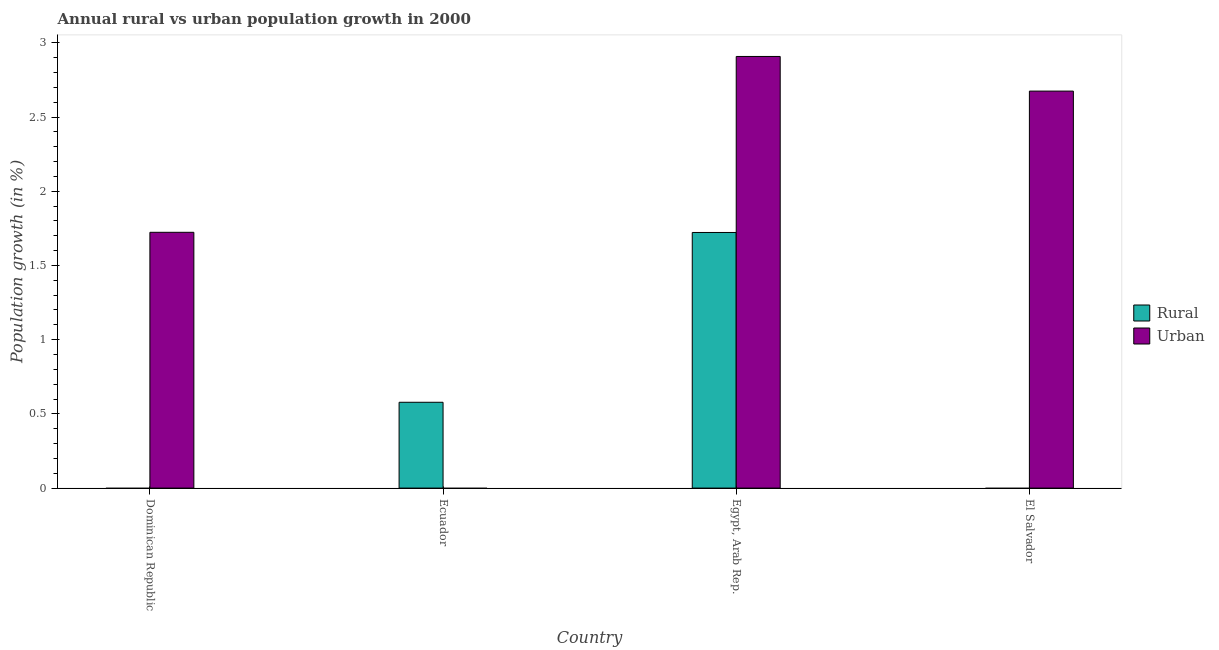How many different coloured bars are there?
Give a very brief answer. 2. Are the number of bars per tick equal to the number of legend labels?
Make the answer very short. No. How many bars are there on the 1st tick from the left?
Provide a short and direct response. 1. What is the label of the 4th group of bars from the left?
Your response must be concise. El Salvador. In how many cases, is the number of bars for a given country not equal to the number of legend labels?
Your answer should be very brief. 3. Across all countries, what is the maximum urban population growth?
Give a very brief answer. 2.91. In which country was the urban population growth maximum?
Offer a terse response. Egypt, Arab Rep. What is the total rural population growth in the graph?
Your answer should be compact. 2.3. What is the difference between the rural population growth in Ecuador and that in Egypt, Arab Rep.?
Provide a short and direct response. -1.14. What is the difference between the rural population growth in Ecuador and the urban population growth in Egypt, Arab Rep.?
Keep it short and to the point. -2.33. What is the average rural population growth per country?
Provide a short and direct response. 0.58. What is the difference between the rural population growth and urban population growth in Egypt, Arab Rep.?
Offer a terse response. -1.19. In how many countries, is the rural population growth greater than 0.8 %?
Offer a very short reply. 1. What is the ratio of the rural population growth in Ecuador to that in Egypt, Arab Rep.?
Ensure brevity in your answer.  0.34. Is the urban population growth in Dominican Republic less than that in El Salvador?
Provide a succinct answer. Yes. What is the difference between the highest and the second highest urban population growth?
Your response must be concise. 0.23. What is the difference between the highest and the lowest urban population growth?
Provide a short and direct response. 2.91. Is the sum of the urban population growth in Dominican Republic and El Salvador greater than the maximum rural population growth across all countries?
Make the answer very short. Yes. How many bars are there?
Provide a succinct answer. 5. Are all the bars in the graph horizontal?
Provide a succinct answer. No. How are the legend labels stacked?
Your answer should be compact. Vertical. What is the title of the graph?
Give a very brief answer. Annual rural vs urban population growth in 2000. What is the label or title of the X-axis?
Your answer should be very brief. Country. What is the label or title of the Y-axis?
Make the answer very short. Population growth (in %). What is the Population growth (in %) in Rural in Dominican Republic?
Offer a terse response. 0. What is the Population growth (in %) in Urban  in Dominican Republic?
Provide a succinct answer. 1.72. What is the Population growth (in %) of Rural in Ecuador?
Your answer should be compact. 0.58. What is the Population growth (in %) in Urban  in Ecuador?
Offer a very short reply. 0. What is the Population growth (in %) in Rural in Egypt, Arab Rep.?
Your answer should be very brief. 1.72. What is the Population growth (in %) in Urban  in Egypt, Arab Rep.?
Provide a short and direct response. 2.91. What is the Population growth (in %) in Rural in El Salvador?
Provide a short and direct response. 0. What is the Population growth (in %) of Urban  in El Salvador?
Keep it short and to the point. 2.67. Across all countries, what is the maximum Population growth (in %) in Rural?
Your answer should be very brief. 1.72. Across all countries, what is the maximum Population growth (in %) in Urban ?
Provide a succinct answer. 2.91. Across all countries, what is the minimum Population growth (in %) of Urban ?
Ensure brevity in your answer.  0. What is the total Population growth (in %) of Rural in the graph?
Give a very brief answer. 2.3. What is the total Population growth (in %) in Urban  in the graph?
Your response must be concise. 7.31. What is the difference between the Population growth (in %) in Urban  in Dominican Republic and that in Egypt, Arab Rep.?
Your answer should be very brief. -1.18. What is the difference between the Population growth (in %) in Urban  in Dominican Republic and that in El Salvador?
Your answer should be very brief. -0.95. What is the difference between the Population growth (in %) of Rural in Ecuador and that in Egypt, Arab Rep.?
Provide a succinct answer. -1.14. What is the difference between the Population growth (in %) in Urban  in Egypt, Arab Rep. and that in El Salvador?
Provide a short and direct response. 0.23. What is the difference between the Population growth (in %) in Rural in Ecuador and the Population growth (in %) in Urban  in Egypt, Arab Rep.?
Your response must be concise. -2.33. What is the difference between the Population growth (in %) in Rural in Ecuador and the Population growth (in %) in Urban  in El Salvador?
Provide a short and direct response. -2.1. What is the difference between the Population growth (in %) in Rural in Egypt, Arab Rep. and the Population growth (in %) in Urban  in El Salvador?
Give a very brief answer. -0.95. What is the average Population growth (in %) of Rural per country?
Provide a short and direct response. 0.58. What is the average Population growth (in %) of Urban  per country?
Make the answer very short. 1.83. What is the difference between the Population growth (in %) in Rural and Population growth (in %) in Urban  in Egypt, Arab Rep.?
Give a very brief answer. -1.19. What is the ratio of the Population growth (in %) in Urban  in Dominican Republic to that in Egypt, Arab Rep.?
Offer a very short reply. 0.59. What is the ratio of the Population growth (in %) of Urban  in Dominican Republic to that in El Salvador?
Provide a short and direct response. 0.64. What is the ratio of the Population growth (in %) of Rural in Ecuador to that in Egypt, Arab Rep.?
Provide a short and direct response. 0.34. What is the ratio of the Population growth (in %) in Urban  in Egypt, Arab Rep. to that in El Salvador?
Your response must be concise. 1.09. What is the difference between the highest and the second highest Population growth (in %) of Urban ?
Your answer should be very brief. 0.23. What is the difference between the highest and the lowest Population growth (in %) of Rural?
Your answer should be very brief. 1.72. What is the difference between the highest and the lowest Population growth (in %) in Urban ?
Ensure brevity in your answer.  2.91. 